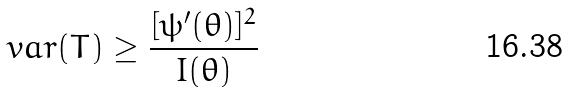Convert formula to latex. <formula><loc_0><loc_0><loc_500><loc_500>v a r ( T ) \geq \frac { [ \psi ^ { \prime } ( \theta ) ] ^ { 2 } } { I ( \theta ) }</formula> 